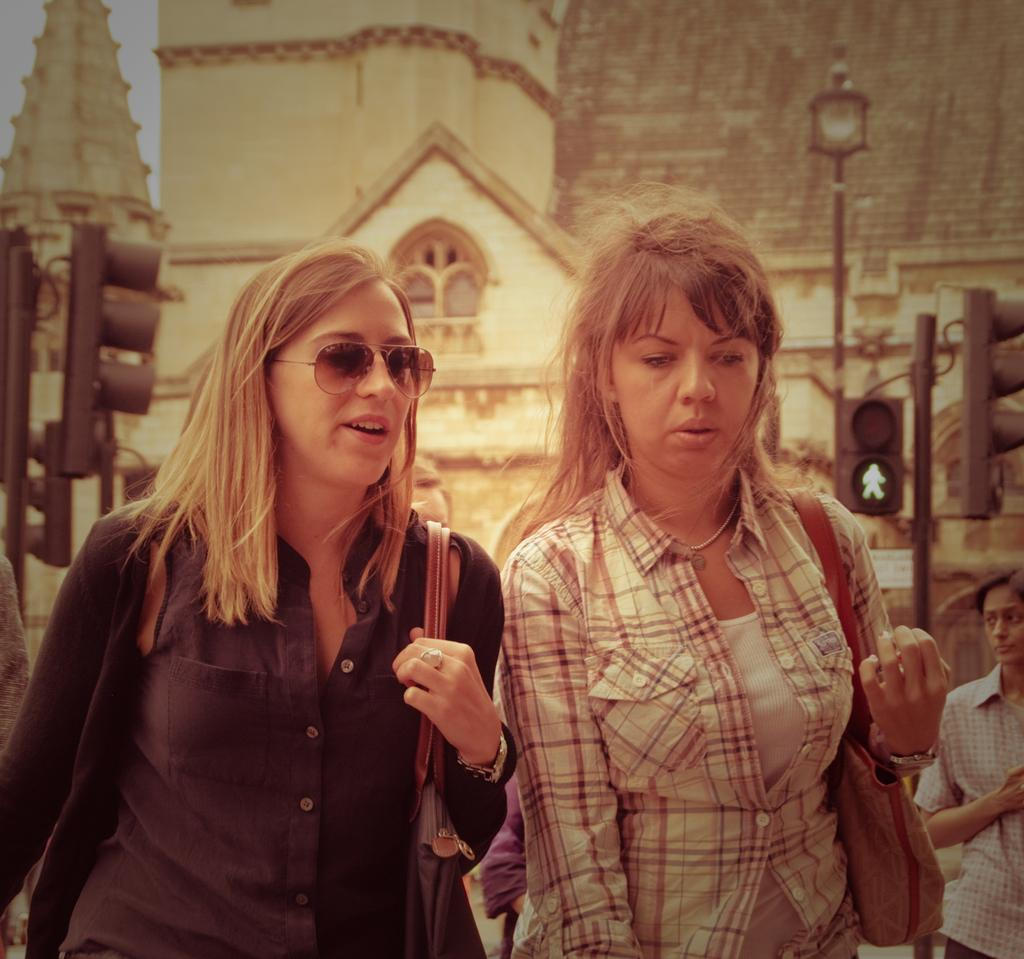Who or what can be seen in the image? There are people in the image. What can be seen in the image that helps regulate traffic? There are traffic signals in the image. What type of structure is visible in the image? There is at least one building in the image. What type of farm animals can be seen grazing on the ground in the image? There is no farm or ground visible in the image, and therefore no farm animals can be observed. 